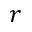Convert formula to latex. <formula><loc_0><loc_0><loc_500><loc_500>r</formula> 